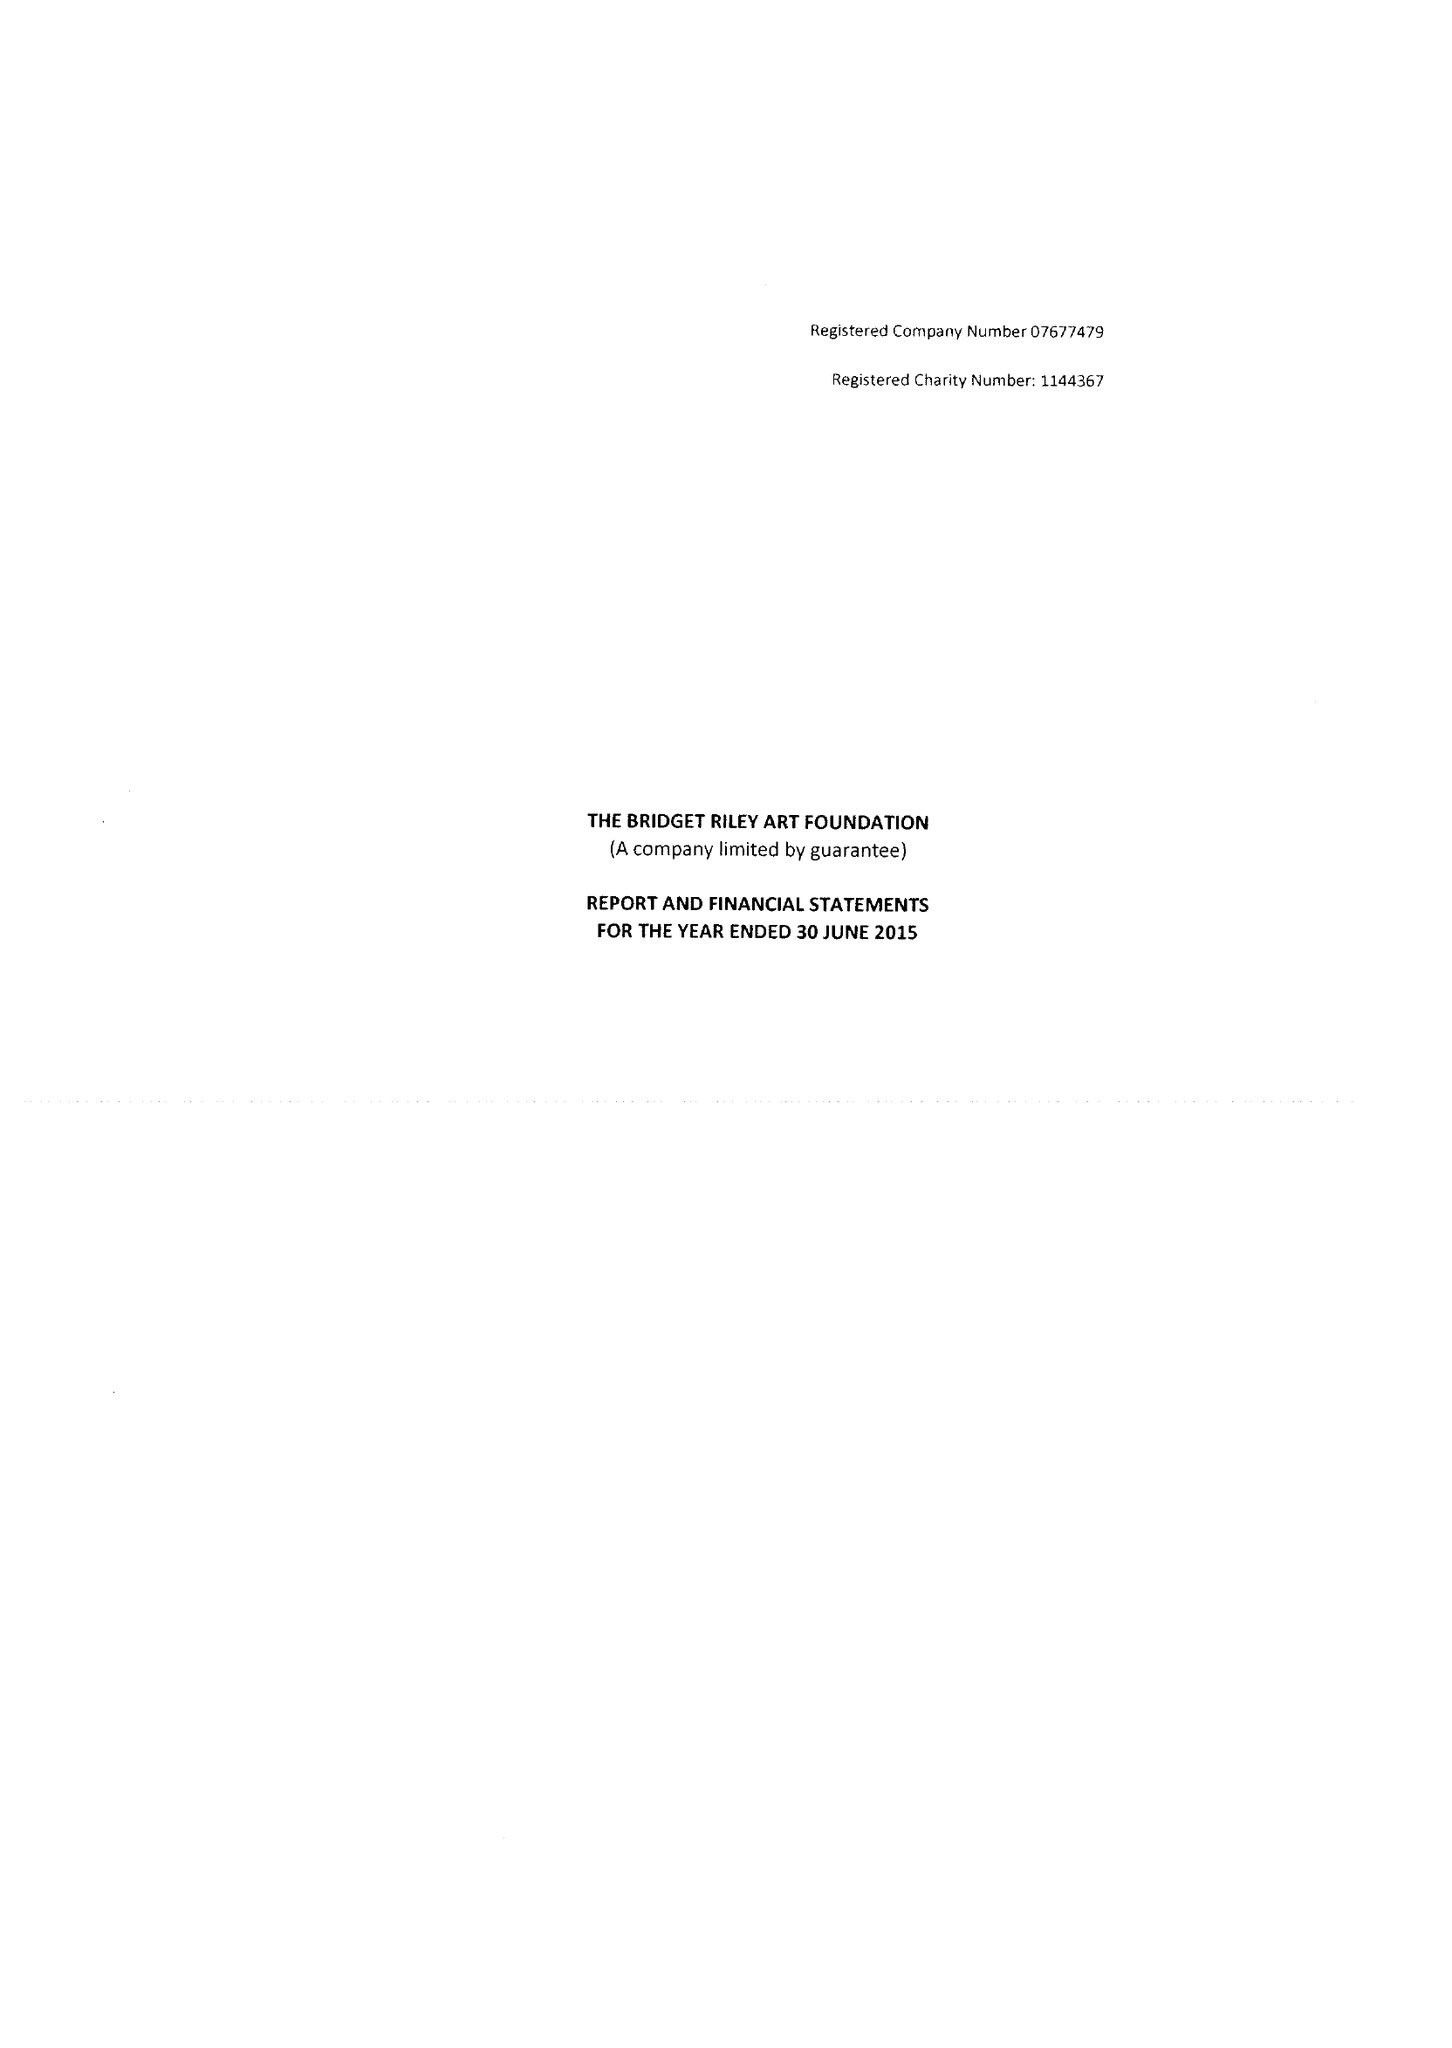What is the value for the report_date?
Answer the question using a single word or phrase. 2015-06-30 